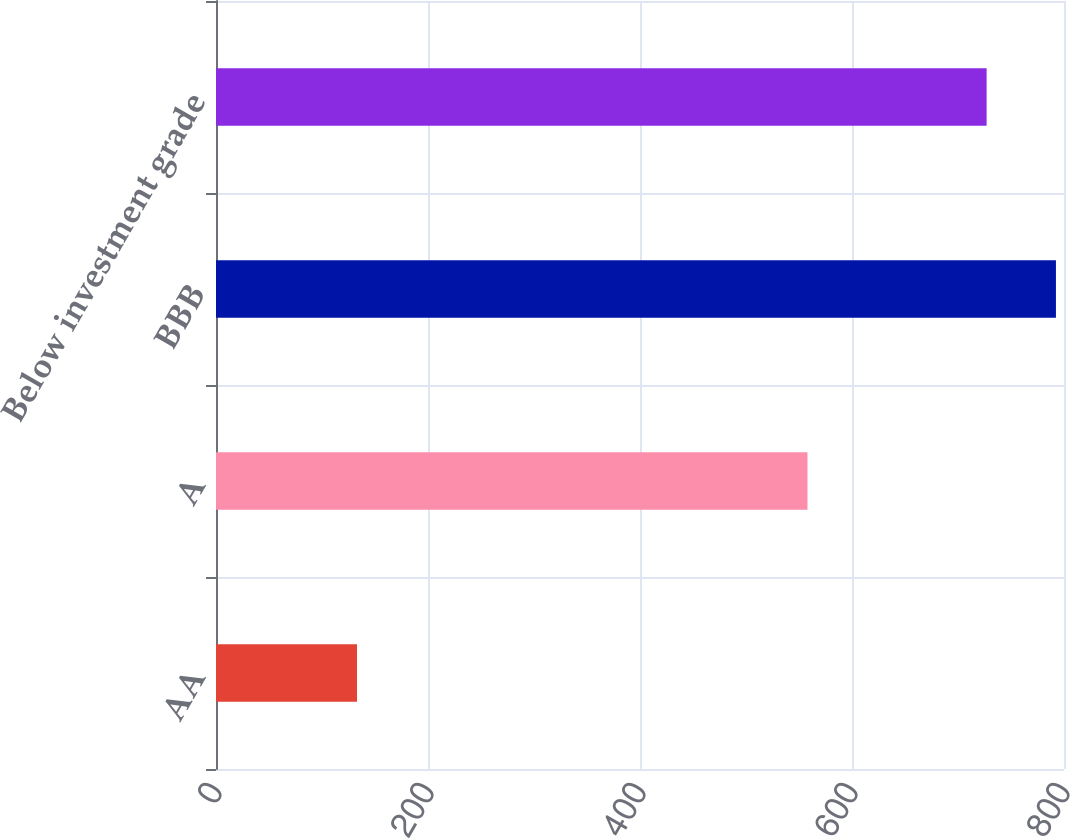Convert chart. <chart><loc_0><loc_0><loc_500><loc_500><bar_chart><fcel>AA<fcel>A<fcel>BBB<fcel>Below investment grade<nl><fcel>133<fcel>558<fcel>792.4<fcel>727<nl></chart> 